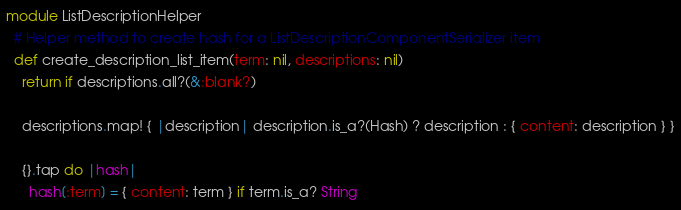Convert code to text. <code><loc_0><loc_0><loc_500><loc_500><_Ruby_>module ListDescriptionHelper
  # Helper method to create hash for a ListDescriptionComponentSerializer item
  def create_description_list_item(term: nil, descriptions: nil)
    return if descriptions.all?(&:blank?)

    descriptions.map! { |description| description.is_a?(Hash) ? description : { content: description } }

    {}.tap do |hash|
      hash[:term] = { content: term } if term.is_a? String</code> 